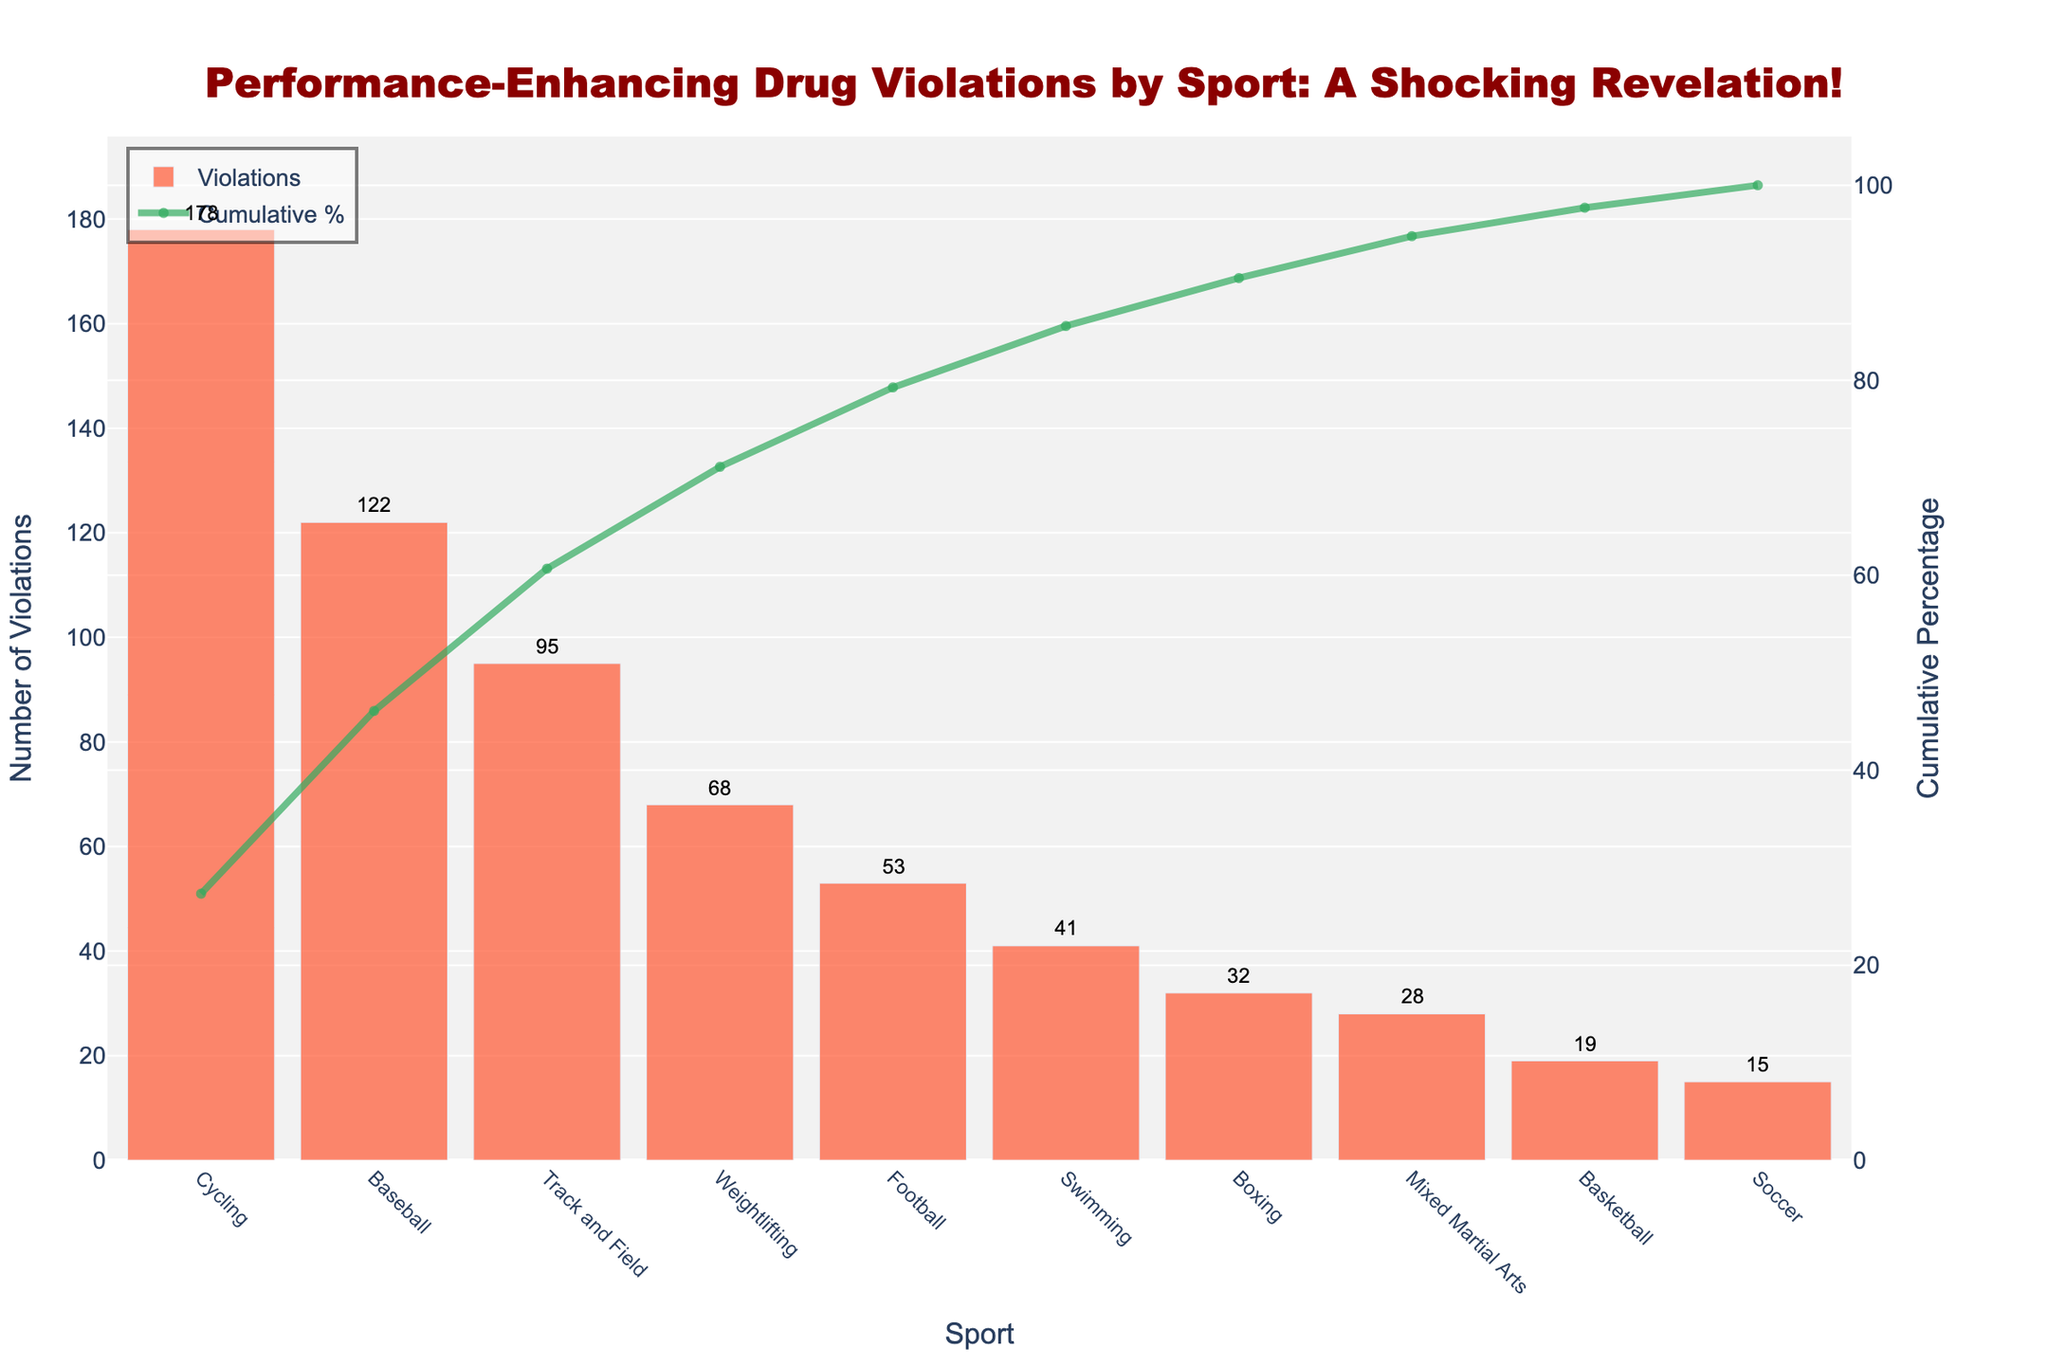What sport has the highest number of performance-enhancing drug violations? The chart shows that the sport with the highest number of violations has the tallest bar on the left. This sport is Cycling.
Answer: Cycling What is the total number of performance-enhancing drug violations across all sports? Adding up all the violations from each sport: 178 + 122 + 95 + 68 + 53 + 41 + 32 + 28 + 19 + 15 = 651.
Answer: 651 What percentage of the total violations is accounted for by Cycling alone? Cycling has 178 violations. The total is 651. Calculate the percentage: (178 / 651) * 100 ≈ 27.3%.
Answer: 27.3% What is the cumulative percentage of violations by the time we include Baseball? The cumulative percentage for Baseball is shown by the line chart right above Baseball’s bar: approximately 46.1%.
Answer: 46.1% Which sport shows approximately 80% of cumulative violations? Check where the cumulative line reaches around 80% and note the corresponding sport. It occurs between Football and Weightlifting, so it’s Weightlifting.
Answer: Weightlifting How many more violations does Track and Field have compared to Boxing? Track and Field has 95 violations, and Boxing has 32. The difference is: 95 - 32 = 63.
Answer: 63 What is the difference in the cumulative percentage between Swimming and Mixed Martial Arts? The cumulative percentage for Swimming is around 78%, and for Mixed Martial Arts, it is around 85.3%. The difference is: 85.3% - 78% = 7.3%.
Answer: 7.3% How many sports have fewer than 30 drug violations? Count the sports with bars shorter than 30: Mixed Martial Arts, Basketball, and Soccer. There are 3 such sports.
Answer: 3 What’s the cumulative percentage after including Weightlifting? The cumulative percentage at Weightlifting (which is fourth on the chart) is shown as approximately 70%.
Answer: 70% Which sport is ranked third in the number of violations? Looking at the third-highest bar on the chart from left, the sport is Track and Field.
Answer: Track and Field 